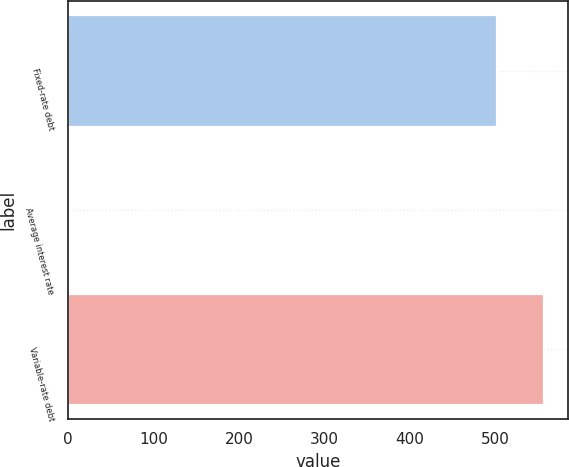Convert chart to OTSL. <chart><loc_0><loc_0><loc_500><loc_500><bar_chart><fcel>Fixed-rate debt<fcel>Average interest rate<fcel>Variable-rate debt<nl><fcel>502<fcel>1.4<fcel>556.86<nl></chart> 